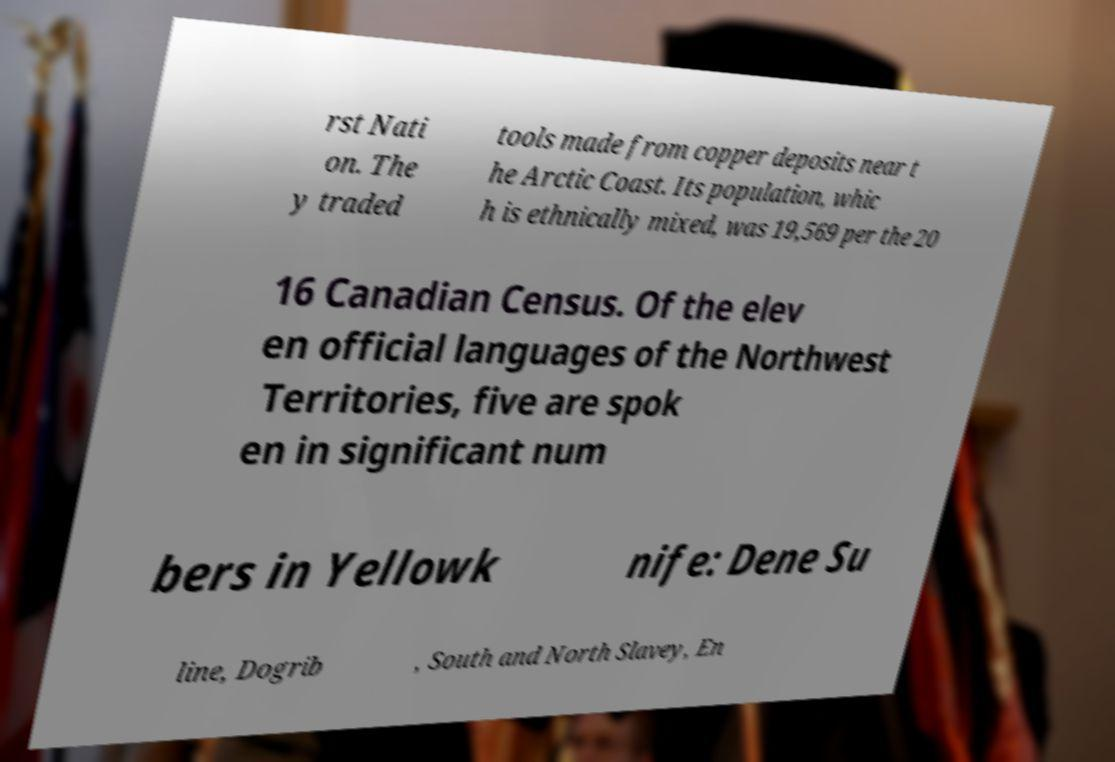For documentation purposes, I need the text within this image transcribed. Could you provide that? rst Nati on. The y traded tools made from copper deposits near t he Arctic Coast. Its population, whic h is ethnically mixed, was 19,569 per the 20 16 Canadian Census. Of the elev en official languages of the Northwest Territories, five are spok en in significant num bers in Yellowk nife: Dene Su line, Dogrib , South and North Slavey, En 